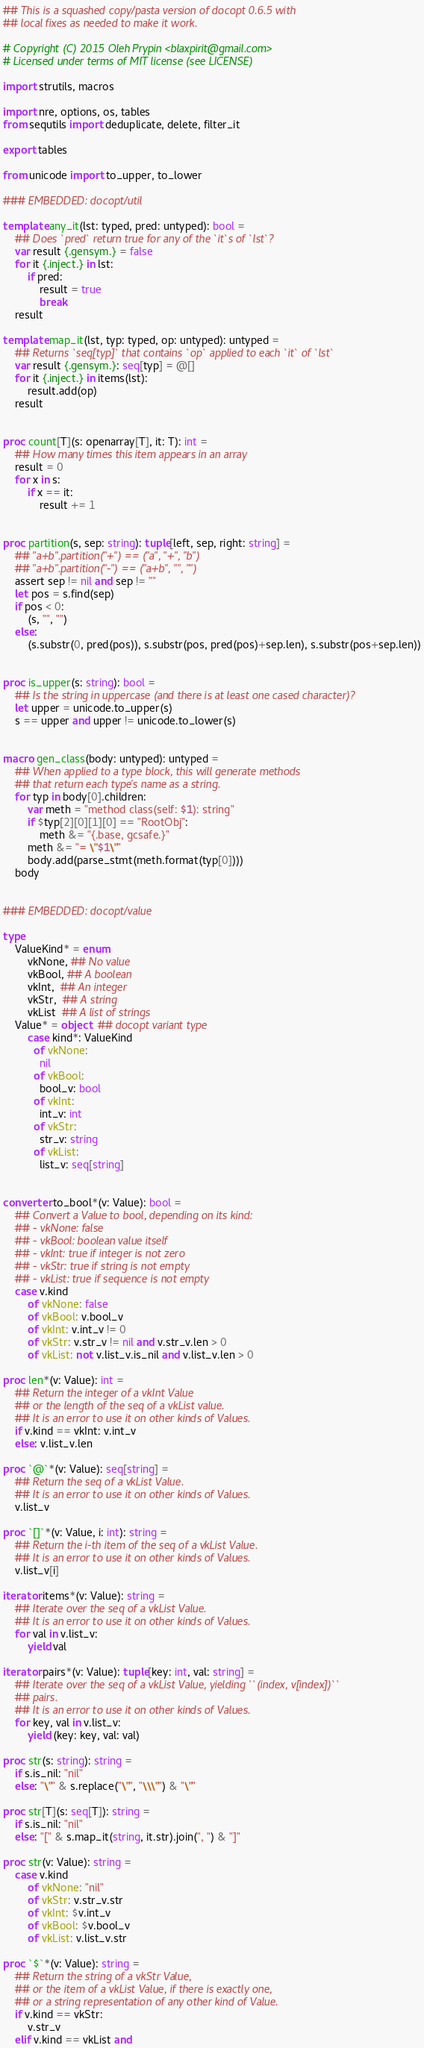<code> <loc_0><loc_0><loc_500><loc_500><_Nim_>## This is a squashed copy/pasta version of docopt 0.6.5 with
## local fixes as needed to make it work.

# Copyright (C) 2015 Oleh Prypin <blaxpirit@gmail.com>
# Licensed under terms of MIT license (see LICENSE)

import strutils, macros

import nre, options, os, tables
from sequtils import deduplicate, delete, filter_it

export tables

from unicode import to_upper, to_lower

### EMBEDDED: docopt/util

template any_it(lst: typed, pred: untyped): bool =
    ## Does `pred` return true for any of the `it`s of `lst`?
    var result {.gensym.} = false
    for it {.inject.} in lst:
        if pred:
            result = true
            break
    result

template map_it(lst, typ: typed, op: untyped): untyped =
    ## Returns `seq[typ]` that contains `op` applied to each `it` of `lst`
    var result {.gensym.}: seq[typ] = @[]
    for it {.inject.} in items(lst):
        result.add(op)
    result


proc count[T](s: openarray[T], it: T): int =
    ## How many times this item appears in an array
    result = 0
    for x in s:
        if x == it:
            result += 1


proc partition(s, sep: string): tuple[left, sep, right: string] =
    ## "a+b".partition("+") == ("a", "+", "b")
    ## "a+b".partition("-") == ("a+b", "", "")
    assert sep != nil and sep != ""
    let pos = s.find(sep)
    if pos < 0:
        (s, "", "")
    else:
        (s.substr(0, pred(pos)), s.substr(pos, pred(pos)+sep.len), s.substr(pos+sep.len))


proc is_upper(s: string): bool =
    ## Is the string in uppercase (and there is at least one cased character)?
    let upper = unicode.to_upper(s)
    s == upper and upper != unicode.to_lower(s)


macro gen_class(body: untyped): untyped =
    ## When applied to a type block, this will generate methods
    ## that return each type's name as a string.
    for typ in body[0].children:
        var meth = "method class(self: $1): string"
        if $typ[2][0][1][0] == "RootObj":
            meth &= "{.base, gcsafe.}"
        meth &= "= \"$1\""
        body.add(parse_stmt(meth.format(typ[0])))
    body


### EMBEDDED: docopt/value

type
    ValueKind* = enum
        vkNone, ## No value
        vkBool, ## A boolean
        vkInt,  ## An integer
        vkStr,  ## A string
        vkList  ## A list of strings
    Value* = object  ## docopt variant type
        case kind*: ValueKind
          of vkNone:
            nil
          of vkBool:
            bool_v: bool
          of vkInt:
            int_v: int
          of vkStr:
            str_v: string
          of vkList:
            list_v: seq[string]


converter to_bool*(v: Value): bool =
    ## Convert a Value to bool, depending on its kind:
    ## - vkNone: false
    ## - vkBool: boolean value itself
    ## - vkInt: true if integer is not zero
    ## - vkStr: true if string is not empty
    ## - vkList: true if sequence is not empty
    case v.kind
        of vkNone: false
        of vkBool: v.bool_v
        of vkInt: v.int_v != 0
        of vkStr: v.str_v != nil and v.str_v.len > 0
        of vkList: not v.list_v.is_nil and v.list_v.len > 0

proc len*(v: Value): int =
    ## Return the integer of a vkInt Value
    ## or the length of the seq of a vkList value.
    ## It is an error to use it on other kinds of Values.
    if v.kind == vkInt: v.int_v
    else: v.list_v.len

proc `@`*(v: Value): seq[string] =
    ## Return the seq of a vkList Value.
    ## It is an error to use it on other kinds of Values.
    v.list_v

proc `[]`*(v: Value, i: int): string =
    ## Return the i-th item of the seq of a vkList Value.
    ## It is an error to use it on other kinds of Values.
    v.list_v[i]

iterator items*(v: Value): string =
    ## Iterate over the seq of a vkList Value.
    ## It is an error to use it on other kinds of Values.
    for val in v.list_v:
        yield val

iterator pairs*(v: Value): tuple[key: int, val: string] =
    ## Iterate over the seq of a vkList Value, yielding ``(index, v[index])``
    ## pairs.
    ## It is an error to use it on other kinds of Values.
    for key, val in v.list_v:
        yield (key: key, val: val)

proc str(s: string): string =
    if s.is_nil: "nil"
    else: "\"" & s.replace("\"", "\\\"") & "\""

proc str[T](s: seq[T]): string =
    if s.is_nil: "nil"
    else: "[" & s.map_it(string, it.str).join(", ") & "]"

proc str(v: Value): string =
    case v.kind
        of vkNone: "nil"
        of vkStr: v.str_v.str
        of vkInt: $v.int_v
        of vkBool: $v.bool_v
        of vkList: v.list_v.str

proc `$`*(v: Value): string =
    ## Return the string of a vkStr Value,
    ## or the item of a vkList Value, if there is exactly one,
    ## or a string representation of any other kind of Value.
    if v.kind == vkStr:
        v.str_v
    elif v.kind == vkList and</code> 